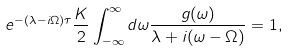<formula> <loc_0><loc_0><loc_500><loc_500>e ^ { - ( \lambda - i \Omega ) \tau } \frac { K } { 2 } \int _ { - \infty } ^ { \infty } d \omega \frac { g ( \omega ) } { \lambda + i ( \omega - \Omega ) } = 1 ,</formula> 